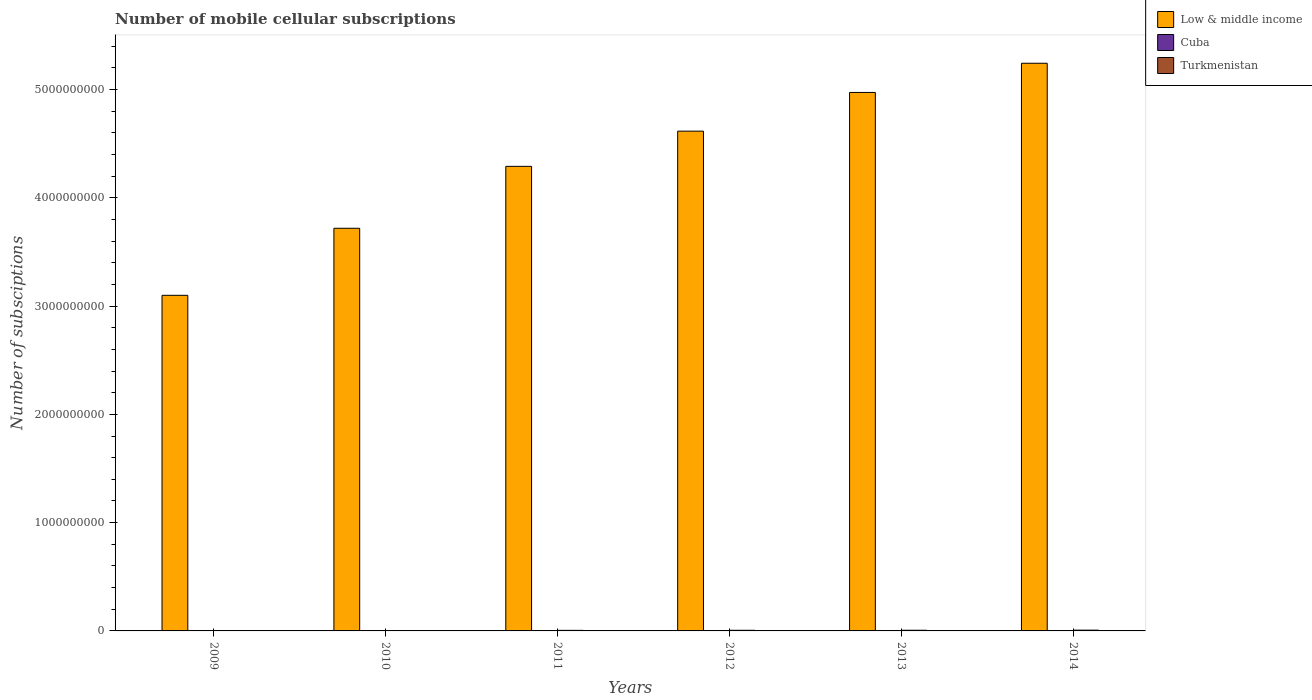Are the number of bars per tick equal to the number of legend labels?
Give a very brief answer. Yes. Are the number of bars on each tick of the X-axis equal?
Offer a terse response. Yes. How many bars are there on the 5th tick from the right?
Offer a very short reply. 3. What is the number of mobile cellular subscriptions in Cuba in 2012?
Offer a terse response. 1.68e+06. Across all years, what is the maximum number of mobile cellular subscriptions in Turkmenistan?
Your response must be concise. 7.21e+06. Across all years, what is the minimum number of mobile cellular subscriptions in Cuba?
Keep it short and to the point. 6.21e+05. In which year was the number of mobile cellular subscriptions in Low & middle income minimum?
Provide a short and direct response. 2009. What is the total number of mobile cellular subscriptions in Turkmenistan in the graph?
Provide a succinct answer. 2.99e+07. What is the difference between the number of mobile cellular subscriptions in Turkmenistan in 2012 and that in 2013?
Your response must be concise. -2.25e+05. What is the difference between the number of mobile cellular subscriptions in Cuba in 2009 and the number of mobile cellular subscriptions in Turkmenistan in 2013?
Your answer should be compact. -5.50e+06. What is the average number of mobile cellular subscriptions in Turkmenistan per year?
Make the answer very short. 4.98e+06. In the year 2010, what is the difference between the number of mobile cellular subscriptions in Cuba and number of mobile cellular subscriptions in Low & middle income?
Provide a succinct answer. -3.72e+09. What is the ratio of the number of mobile cellular subscriptions in Turkmenistan in 2012 to that in 2014?
Your answer should be very brief. 0.82. Is the difference between the number of mobile cellular subscriptions in Cuba in 2010 and 2011 greater than the difference between the number of mobile cellular subscriptions in Low & middle income in 2010 and 2011?
Provide a short and direct response. Yes. What is the difference between the highest and the second highest number of mobile cellular subscriptions in Low & middle income?
Provide a succinct answer. 2.70e+08. What is the difference between the highest and the lowest number of mobile cellular subscriptions in Low & middle income?
Your answer should be compact. 2.14e+09. In how many years, is the number of mobile cellular subscriptions in Low & middle income greater than the average number of mobile cellular subscriptions in Low & middle income taken over all years?
Offer a very short reply. 3. What does the 1st bar from the left in 2013 represents?
Offer a very short reply. Low & middle income. What does the 2nd bar from the right in 2010 represents?
Make the answer very short. Cuba. How many bars are there?
Ensure brevity in your answer.  18. Are all the bars in the graph horizontal?
Your response must be concise. No. How many years are there in the graph?
Provide a succinct answer. 6. What is the difference between two consecutive major ticks on the Y-axis?
Your answer should be very brief. 1.00e+09. Are the values on the major ticks of Y-axis written in scientific E-notation?
Your answer should be compact. No. Does the graph contain grids?
Ensure brevity in your answer.  No. Where does the legend appear in the graph?
Offer a terse response. Top right. How many legend labels are there?
Make the answer very short. 3. What is the title of the graph?
Give a very brief answer. Number of mobile cellular subscriptions. What is the label or title of the X-axis?
Keep it short and to the point. Years. What is the label or title of the Y-axis?
Give a very brief answer. Number of subsciptions. What is the Number of subsciptions of Low & middle income in 2009?
Provide a short and direct response. 3.10e+09. What is the Number of subsciptions in Cuba in 2009?
Your response must be concise. 6.21e+05. What is the Number of subsciptions of Turkmenistan in 2009?
Offer a very short reply. 2.13e+06. What is the Number of subsciptions in Low & middle income in 2010?
Make the answer very short. 3.72e+09. What is the Number of subsciptions in Cuba in 2010?
Provide a short and direct response. 1.00e+06. What is the Number of subsciptions in Turkmenistan in 2010?
Offer a terse response. 3.20e+06. What is the Number of subsciptions in Low & middle income in 2011?
Provide a succinct answer. 4.29e+09. What is the Number of subsciptions in Cuba in 2011?
Make the answer very short. 1.32e+06. What is the Number of subsciptions of Turkmenistan in 2011?
Your answer should be very brief. 5.30e+06. What is the Number of subsciptions in Low & middle income in 2012?
Your answer should be compact. 4.62e+09. What is the Number of subsciptions of Cuba in 2012?
Your answer should be very brief. 1.68e+06. What is the Number of subsciptions of Turkmenistan in 2012?
Offer a terse response. 5.90e+06. What is the Number of subsciptions in Low & middle income in 2013?
Provide a succinct answer. 4.97e+09. What is the Number of subsciptions of Cuba in 2013?
Make the answer very short. 2.00e+06. What is the Number of subsciptions in Turkmenistan in 2013?
Your answer should be compact. 6.13e+06. What is the Number of subsciptions in Low & middle income in 2014?
Keep it short and to the point. 5.24e+09. What is the Number of subsciptions of Cuba in 2014?
Ensure brevity in your answer.  2.53e+06. What is the Number of subsciptions of Turkmenistan in 2014?
Give a very brief answer. 7.21e+06. Across all years, what is the maximum Number of subsciptions of Low & middle income?
Give a very brief answer. 5.24e+09. Across all years, what is the maximum Number of subsciptions of Cuba?
Keep it short and to the point. 2.53e+06. Across all years, what is the maximum Number of subsciptions in Turkmenistan?
Make the answer very short. 7.21e+06. Across all years, what is the minimum Number of subsciptions of Low & middle income?
Your response must be concise. 3.10e+09. Across all years, what is the minimum Number of subsciptions of Cuba?
Provide a short and direct response. 6.21e+05. Across all years, what is the minimum Number of subsciptions of Turkmenistan?
Offer a terse response. 2.13e+06. What is the total Number of subsciptions of Low & middle income in the graph?
Make the answer very short. 2.59e+1. What is the total Number of subsciptions of Cuba in the graph?
Offer a terse response. 9.15e+06. What is the total Number of subsciptions of Turkmenistan in the graph?
Provide a succinct answer. 2.99e+07. What is the difference between the Number of subsciptions in Low & middle income in 2009 and that in 2010?
Provide a succinct answer. -6.19e+08. What is the difference between the Number of subsciptions in Cuba in 2009 and that in 2010?
Make the answer very short. -3.82e+05. What is the difference between the Number of subsciptions in Turkmenistan in 2009 and that in 2010?
Your response must be concise. -1.06e+06. What is the difference between the Number of subsciptions in Low & middle income in 2009 and that in 2011?
Offer a very short reply. -1.19e+09. What is the difference between the Number of subsciptions of Cuba in 2009 and that in 2011?
Make the answer very short. -6.94e+05. What is the difference between the Number of subsciptions of Turkmenistan in 2009 and that in 2011?
Ensure brevity in your answer.  -3.17e+06. What is the difference between the Number of subsciptions of Low & middle income in 2009 and that in 2012?
Offer a terse response. -1.52e+09. What is the difference between the Number of subsciptions of Cuba in 2009 and that in 2012?
Ensure brevity in your answer.  -1.06e+06. What is the difference between the Number of subsciptions in Turkmenistan in 2009 and that in 2012?
Ensure brevity in your answer.  -3.77e+06. What is the difference between the Number of subsciptions of Low & middle income in 2009 and that in 2013?
Your answer should be very brief. -1.87e+09. What is the difference between the Number of subsciptions of Cuba in 2009 and that in 2013?
Make the answer very short. -1.37e+06. What is the difference between the Number of subsciptions in Turkmenistan in 2009 and that in 2013?
Provide a succinct answer. -3.99e+06. What is the difference between the Number of subsciptions of Low & middle income in 2009 and that in 2014?
Your response must be concise. -2.14e+09. What is the difference between the Number of subsciptions in Cuba in 2009 and that in 2014?
Offer a terse response. -1.91e+06. What is the difference between the Number of subsciptions in Turkmenistan in 2009 and that in 2014?
Make the answer very short. -5.07e+06. What is the difference between the Number of subsciptions of Low & middle income in 2010 and that in 2011?
Offer a terse response. -5.72e+08. What is the difference between the Number of subsciptions in Cuba in 2010 and that in 2011?
Offer a terse response. -3.12e+05. What is the difference between the Number of subsciptions of Turkmenistan in 2010 and that in 2011?
Offer a terse response. -2.10e+06. What is the difference between the Number of subsciptions of Low & middle income in 2010 and that in 2012?
Offer a very short reply. -8.97e+08. What is the difference between the Number of subsciptions in Cuba in 2010 and that in 2012?
Provide a succinct answer. -6.79e+05. What is the difference between the Number of subsciptions in Turkmenistan in 2010 and that in 2012?
Ensure brevity in your answer.  -2.70e+06. What is the difference between the Number of subsciptions of Low & middle income in 2010 and that in 2013?
Your answer should be very brief. -1.25e+09. What is the difference between the Number of subsciptions in Cuba in 2010 and that in 2013?
Your response must be concise. -9.93e+05. What is the difference between the Number of subsciptions in Turkmenistan in 2010 and that in 2013?
Offer a very short reply. -2.93e+06. What is the difference between the Number of subsciptions in Low & middle income in 2010 and that in 2014?
Offer a very short reply. -1.52e+09. What is the difference between the Number of subsciptions of Cuba in 2010 and that in 2014?
Offer a very short reply. -1.53e+06. What is the difference between the Number of subsciptions of Turkmenistan in 2010 and that in 2014?
Provide a succinct answer. -4.01e+06. What is the difference between the Number of subsciptions in Low & middle income in 2011 and that in 2012?
Offer a terse response. -3.25e+08. What is the difference between the Number of subsciptions of Cuba in 2011 and that in 2012?
Your answer should be compact. -3.67e+05. What is the difference between the Number of subsciptions of Turkmenistan in 2011 and that in 2012?
Your answer should be very brief. -6.00e+05. What is the difference between the Number of subsciptions in Low & middle income in 2011 and that in 2013?
Your answer should be compact. -6.82e+08. What is the difference between the Number of subsciptions of Cuba in 2011 and that in 2013?
Give a very brief answer. -6.81e+05. What is the difference between the Number of subsciptions in Turkmenistan in 2011 and that in 2013?
Offer a very short reply. -8.25e+05. What is the difference between the Number of subsciptions in Low & middle income in 2011 and that in 2014?
Your answer should be compact. -9.52e+08. What is the difference between the Number of subsciptions in Cuba in 2011 and that in 2014?
Provide a short and direct response. -1.22e+06. What is the difference between the Number of subsciptions in Turkmenistan in 2011 and that in 2014?
Offer a terse response. -1.91e+06. What is the difference between the Number of subsciptions in Low & middle income in 2012 and that in 2013?
Offer a very short reply. -3.57e+08. What is the difference between the Number of subsciptions of Cuba in 2012 and that in 2013?
Keep it short and to the point. -3.14e+05. What is the difference between the Number of subsciptions of Turkmenistan in 2012 and that in 2013?
Give a very brief answer. -2.25e+05. What is the difference between the Number of subsciptions in Low & middle income in 2012 and that in 2014?
Give a very brief answer. -6.27e+08. What is the difference between the Number of subsciptions of Cuba in 2012 and that in 2014?
Offer a terse response. -8.49e+05. What is the difference between the Number of subsciptions of Turkmenistan in 2012 and that in 2014?
Ensure brevity in your answer.  -1.31e+06. What is the difference between the Number of subsciptions of Low & middle income in 2013 and that in 2014?
Your response must be concise. -2.70e+08. What is the difference between the Number of subsciptions in Cuba in 2013 and that in 2014?
Your answer should be very brief. -5.35e+05. What is the difference between the Number of subsciptions of Turkmenistan in 2013 and that in 2014?
Provide a short and direct response. -1.08e+06. What is the difference between the Number of subsciptions of Low & middle income in 2009 and the Number of subsciptions of Cuba in 2010?
Your answer should be compact. 3.10e+09. What is the difference between the Number of subsciptions of Low & middle income in 2009 and the Number of subsciptions of Turkmenistan in 2010?
Provide a succinct answer. 3.10e+09. What is the difference between the Number of subsciptions of Cuba in 2009 and the Number of subsciptions of Turkmenistan in 2010?
Your answer should be compact. -2.58e+06. What is the difference between the Number of subsciptions of Low & middle income in 2009 and the Number of subsciptions of Cuba in 2011?
Provide a succinct answer. 3.10e+09. What is the difference between the Number of subsciptions of Low & middle income in 2009 and the Number of subsciptions of Turkmenistan in 2011?
Ensure brevity in your answer.  3.09e+09. What is the difference between the Number of subsciptions of Cuba in 2009 and the Number of subsciptions of Turkmenistan in 2011?
Your answer should be compact. -4.68e+06. What is the difference between the Number of subsciptions of Low & middle income in 2009 and the Number of subsciptions of Cuba in 2012?
Provide a short and direct response. 3.10e+09. What is the difference between the Number of subsciptions in Low & middle income in 2009 and the Number of subsciptions in Turkmenistan in 2012?
Make the answer very short. 3.09e+09. What is the difference between the Number of subsciptions of Cuba in 2009 and the Number of subsciptions of Turkmenistan in 2012?
Your response must be concise. -5.28e+06. What is the difference between the Number of subsciptions in Low & middle income in 2009 and the Number of subsciptions in Cuba in 2013?
Offer a terse response. 3.10e+09. What is the difference between the Number of subsciptions in Low & middle income in 2009 and the Number of subsciptions in Turkmenistan in 2013?
Offer a terse response. 3.09e+09. What is the difference between the Number of subsciptions in Cuba in 2009 and the Number of subsciptions in Turkmenistan in 2013?
Offer a very short reply. -5.50e+06. What is the difference between the Number of subsciptions in Low & middle income in 2009 and the Number of subsciptions in Cuba in 2014?
Keep it short and to the point. 3.10e+09. What is the difference between the Number of subsciptions in Low & middle income in 2009 and the Number of subsciptions in Turkmenistan in 2014?
Give a very brief answer. 3.09e+09. What is the difference between the Number of subsciptions in Cuba in 2009 and the Number of subsciptions in Turkmenistan in 2014?
Your answer should be very brief. -6.58e+06. What is the difference between the Number of subsciptions of Low & middle income in 2010 and the Number of subsciptions of Cuba in 2011?
Your response must be concise. 3.72e+09. What is the difference between the Number of subsciptions of Low & middle income in 2010 and the Number of subsciptions of Turkmenistan in 2011?
Your answer should be compact. 3.71e+09. What is the difference between the Number of subsciptions in Cuba in 2010 and the Number of subsciptions in Turkmenistan in 2011?
Ensure brevity in your answer.  -4.30e+06. What is the difference between the Number of subsciptions of Low & middle income in 2010 and the Number of subsciptions of Cuba in 2012?
Your answer should be very brief. 3.72e+09. What is the difference between the Number of subsciptions in Low & middle income in 2010 and the Number of subsciptions in Turkmenistan in 2012?
Keep it short and to the point. 3.71e+09. What is the difference between the Number of subsciptions of Cuba in 2010 and the Number of subsciptions of Turkmenistan in 2012?
Give a very brief answer. -4.90e+06. What is the difference between the Number of subsciptions in Low & middle income in 2010 and the Number of subsciptions in Cuba in 2013?
Your answer should be compact. 3.72e+09. What is the difference between the Number of subsciptions in Low & middle income in 2010 and the Number of subsciptions in Turkmenistan in 2013?
Offer a terse response. 3.71e+09. What is the difference between the Number of subsciptions in Cuba in 2010 and the Number of subsciptions in Turkmenistan in 2013?
Keep it short and to the point. -5.12e+06. What is the difference between the Number of subsciptions in Low & middle income in 2010 and the Number of subsciptions in Cuba in 2014?
Your answer should be compact. 3.72e+09. What is the difference between the Number of subsciptions in Low & middle income in 2010 and the Number of subsciptions in Turkmenistan in 2014?
Keep it short and to the point. 3.71e+09. What is the difference between the Number of subsciptions in Cuba in 2010 and the Number of subsciptions in Turkmenistan in 2014?
Offer a terse response. -6.20e+06. What is the difference between the Number of subsciptions in Low & middle income in 2011 and the Number of subsciptions in Cuba in 2012?
Provide a succinct answer. 4.29e+09. What is the difference between the Number of subsciptions in Low & middle income in 2011 and the Number of subsciptions in Turkmenistan in 2012?
Offer a terse response. 4.28e+09. What is the difference between the Number of subsciptions in Cuba in 2011 and the Number of subsciptions in Turkmenistan in 2012?
Make the answer very short. -4.58e+06. What is the difference between the Number of subsciptions in Low & middle income in 2011 and the Number of subsciptions in Cuba in 2013?
Provide a succinct answer. 4.29e+09. What is the difference between the Number of subsciptions of Low & middle income in 2011 and the Number of subsciptions of Turkmenistan in 2013?
Ensure brevity in your answer.  4.28e+09. What is the difference between the Number of subsciptions in Cuba in 2011 and the Number of subsciptions in Turkmenistan in 2013?
Offer a terse response. -4.81e+06. What is the difference between the Number of subsciptions in Low & middle income in 2011 and the Number of subsciptions in Cuba in 2014?
Your response must be concise. 4.29e+09. What is the difference between the Number of subsciptions of Low & middle income in 2011 and the Number of subsciptions of Turkmenistan in 2014?
Make the answer very short. 4.28e+09. What is the difference between the Number of subsciptions in Cuba in 2011 and the Number of subsciptions in Turkmenistan in 2014?
Offer a terse response. -5.89e+06. What is the difference between the Number of subsciptions of Low & middle income in 2012 and the Number of subsciptions of Cuba in 2013?
Provide a succinct answer. 4.61e+09. What is the difference between the Number of subsciptions of Low & middle income in 2012 and the Number of subsciptions of Turkmenistan in 2013?
Offer a terse response. 4.61e+09. What is the difference between the Number of subsciptions of Cuba in 2012 and the Number of subsciptions of Turkmenistan in 2013?
Offer a terse response. -4.44e+06. What is the difference between the Number of subsciptions in Low & middle income in 2012 and the Number of subsciptions in Cuba in 2014?
Ensure brevity in your answer.  4.61e+09. What is the difference between the Number of subsciptions of Low & middle income in 2012 and the Number of subsciptions of Turkmenistan in 2014?
Make the answer very short. 4.61e+09. What is the difference between the Number of subsciptions of Cuba in 2012 and the Number of subsciptions of Turkmenistan in 2014?
Your response must be concise. -5.52e+06. What is the difference between the Number of subsciptions of Low & middle income in 2013 and the Number of subsciptions of Cuba in 2014?
Offer a very short reply. 4.97e+09. What is the difference between the Number of subsciptions in Low & middle income in 2013 and the Number of subsciptions in Turkmenistan in 2014?
Your answer should be very brief. 4.97e+09. What is the difference between the Number of subsciptions of Cuba in 2013 and the Number of subsciptions of Turkmenistan in 2014?
Your response must be concise. -5.21e+06. What is the average Number of subsciptions of Low & middle income per year?
Provide a short and direct response. 4.32e+09. What is the average Number of subsciptions of Cuba per year?
Your answer should be very brief. 1.52e+06. What is the average Number of subsciptions of Turkmenistan per year?
Give a very brief answer. 4.98e+06. In the year 2009, what is the difference between the Number of subsciptions of Low & middle income and Number of subsciptions of Cuba?
Keep it short and to the point. 3.10e+09. In the year 2009, what is the difference between the Number of subsciptions in Low & middle income and Number of subsciptions in Turkmenistan?
Offer a terse response. 3.10e+09. In the year 2009, what is the difference between the Number of subsciptions in Cuba and Number of subsciptions in Turkmenistan?
Offer a terse response. -1.51e+06. In the year 2010, what is the difference between the Number of subsciptions of Low & middle income and Number of subsciptions of Cuba?
Make the answer very short. 3.72e+09. In the year 2010, what is the difference between the Number of subsciptions of Low & middle income and Number of subsciptions of Turkmenistan?
Ensure brevity in your answer.  3.72e+09. In the year 2010, what is the difference between the Number of subsciptions of Cuba and Number of subsciptions of Turkmenistan?
Make the answer very short. -2.19e+06. In the year 2011, what is the difference between the Number of subsciptions in Low & middle income and Number of subsciptions in Cuba?
Give a very brief answer. 4.29e+09. In the year 2011, what is the difference between the Number of subsciptions of Low & middle income and Number of subsciptions of Turkmenistan?
Offer a very short reply. 4.29e+09. In the year 2011, what is the difference between the Number of subsciptions of Cuba and Number of subsciptions of Turkmenistan?
Your answer should be very brief. -3.98e+06. In the year 2012, what is the difference between the Number of subsciptions of Low & middle income and Number of subsciptions of Cuba?
Provide a succinct answer. 4.61e+09. In the year 2012, what is the difference between the Number of subsciptions in Low & middle income and Number of subsciptions in Turkmenistan?
Give a very brief answer. 4.61e+09. In the year 2012, what is the difference between the Number of subsciptions in Cuba and Number of subsciptions in Turkmenistan?
Ensure brevity in your answer.  -4.22e+06. In the year 2013, what is the difference between the Number of subsciptions in Low & middle income and Number of subsciptions in Cuba?
Ensure brevity in your answer.  4.97e+09. In the year 2013, what is the difference between the Number of subsciptions in Low & middle income and Number of subsciptions in Turkmenistan?
Your answer should be very brief. 4.97e+09. In the year 2013, what is the difference between the Number of subsciptions of Cuba and Number of subsciptions of Turkmenistan?
Your answer should be compact. -4.13e+06. In the year 2014, what is the difference between the Number of subsciptions of Low & middle income and Number of subsciptions of Cuba?
Provide a succinct answer. 5.24e+09. In the year 2014, what is the difference between the Number of subsciptions in Low & middle income and Number of subsciptions in Turkmenistan?
Keep it short and to the point. 5.24e+09. In the year 2014, what is the difference between the Number of subsciptions in Cuba and Number of subsciptions in Turkmenistan?
Offer a very short reply. -4.68e+06. What is the ratio of the Number of subsciptions in Low & middle income in 2009 to that in 2010?
Your answer should be very brief. 0.83. What is the ratio of the Number of subsciptions of Cuba in 2009 to that in 2010?
Offer a terse response. 0.62. What is the ratio of the Number of subsciptions of Turkmenistan in 2009 to that in 2010?
Your response must be concise. 0.67. What is the ratio of the Number of subsciptions in Low & middle income in 2009 to that in 2011?
Give a very brief answer. 0.72. What is the ratio of the Number of subsciptions in Cuba in 2009 to that in 2011?
Offer a very short reply. 0.47. What is the ratio of the Number of subsciptions in Turkmenistan in 2009 to that in 2011?
Your answer should be compact. 0.4. What is the ratio of the Number of subsciptions in Low & middle income in 2009 to that in 2012?
Offer a very short reply. 0.67. What is the ratio of the Number of subsciptions in Cuba in 2009 to that in 2012?
Offer a very short reply. 0.37. What is the ratio of the Number of subsciptions of Turkmenistan in 2009 to that in 2012?
Your answer should be compact. 0.36. What is the ratio of the Number of subsciptions in Low & middle income in 2009 to that in 2013?
Make the answer very short. 0.62. What is the ratio of the Number of subsciptions in Cuba in 2009 to that in 2013?
Make the answer very short. 0.31. What is the ratio of the Number of subsciptions in Turkmenistan in 2009 to that in 2013?
Make the answer very short. 0.35. What is the ratio of the Number of subsciptions of Low & middle income in 2009 to that in 2014?
Your response must be concise. 0.59. What is the ratio of the Number of subsciptions of Cuba in 2009 to that in 2014?
Give a very brief answer. 0.25. What is the ratio of the Number of subsciptions of Turkmenistan in 2009 to that in 2014?
Give a very brief answer. 0.3. What is the ratio of the Number of subsciptions of Low & middle income in 2010 to that in 2011?
Offer a terse response. 0.87. What is the ratio of the Number of subsciptions of Cuba in 2010 to that in 2011?
Keep it short and to the point. 0.76. What is the ratio of the Number of subsciptions in Turkmenistan in 2010 to that in 2011?
Offer a terse response. 0.6. What is the ratio of the Number of subsciptions in Low & middle income in 2010 to that in 2012?
Make the answer very short. 0.81. What is the ratio of the Number of subsciptions of Cuba in 2010 to that in 2012?
Make the answer very short. 0.6. What is the ratio of the Number of subsciptions in Turkmenistan in 2010 to that in 2012?
Give a very brief answer. 0.54. What is the ratio of the Number of subsciptions in Low & middle income in 2010 to that in 2013?
Keep it short and to the point. 0.75. What is the ratio of the Number of subsciptions in Cuba in 2010 to that in 2013?
Ensure brevity in your answer.  0.5. What is the ratio of the Number of subsciptions of Turkmenistan in 2010 to that in 2013?
Ensure brevity in your answer.  0.52. What is the ratio of the Number of subsciptions of Low & middle income in 2010 to that in 2014?
Offer a terse response. 0.71. What is the ratio of the Number of subsciptions of Cuba in 2010 to that in 2014?
Provide a succinct answer. 0.4. What is the ratio of the Number of subsciptions in Turkmenistan in 2010 to that in 2014?
Your answer should be very brief. 0.44. What is the ratio of the Number of subsciptions of Low & middle income in 2011 to that in 2012?
Give a very brief answer. 0.93. What is the ratio of the Number of subsciptions of Cuba in 2011 to that in 2012?
Your response must be concise. 0.78. What is the ratio of the Number of subsciptions in Turkmenistan in 2011 to that in 2012?
Offer a very short reply. 0.9. What is the ratio of the Number of subsciptions of Low & middle income in 2011 to that in 2013?
Ensure brevity in your answer.  0.86. What is the ratio of the Number of subsciptions of Cuba in 2011 to that in 2013?
Offer a very short reply. 0.66. What is the ratio of the Number of subsciptions in Turkmenistan in 2011 to that in 2013?
Your response must be concise. 0.87. What is the ratio of the Number of subsciptions of Low & middle income in 2011 to that in 2014?
Give a very brief answer. 0.82. What is the ratio of the Number of subsciptions of Cuba in 2011 to that in 2014?
Offer a terse response. 0.52. What is the ratio of the Number of subsciptions in Turkmenistan in 2011 to that in 2014?
Your response must be concise. 0.74. What is the ratio of the Number of subsciptions of Low & middle income in 2012 to that in 2013?
Offer a terse response. 0.93. What is the ratio of the Number of subsciptions in Cuba in 2012 to that in 2013?
Offer a very short reply. 0.84. What is the ratio of the Number of subsciptions in Turkmenistan in 2012 to that in 2013?
Provide a succinct answer. 0.96. What is the ratio of the Number of subsciptions of Low & middle income in 2012 to that in 2014?
Your answer should be very brief. 0.88. What is the ratio of the Number of subsciptions of Cuba in 2012 to that in 2014?
Offer a very short reply. 0.66. What is the ratio of the Number of subsciptions of Turkmenistan in 2012 to that in 2014?
Your answer should be compact. 0.82. What is the ratio of the Number of subsciptions in Low & middle income in 2013 to that in 2014?
Provide a short and direct response. 0.95. What is the ratio of the Number of subsciptions of Cuba in 2013 to that in 2014?
Your answer should be very brief. 0.79. What is the difference between the highest and the second highest Number of subsciptions of Low & middle income?
Provide a short and direct response. 2.70e+08. What is the difference between the highest and the second highest Number of subsciptions in Cuba?
Keep it short and to the point. 5.35e+05. What is the difference between the highest and the second highest Number of subsciptions of Turkmenistan?
Your answer should be compact. 1.08e+06. What is the difference between the highest and the lowest Number of subsciptions in Low & middle income?
Your response must be concise. 2.14e+09. What is the difference between the highest and the lowest Number of subsciptions in Cuba?
Your answer should be compact. 1.91e+06. What is the difference between the highest and the lowest Number of subsciptions in Turkmenistan?
Provide a succinct answer. 5.07e+06. 